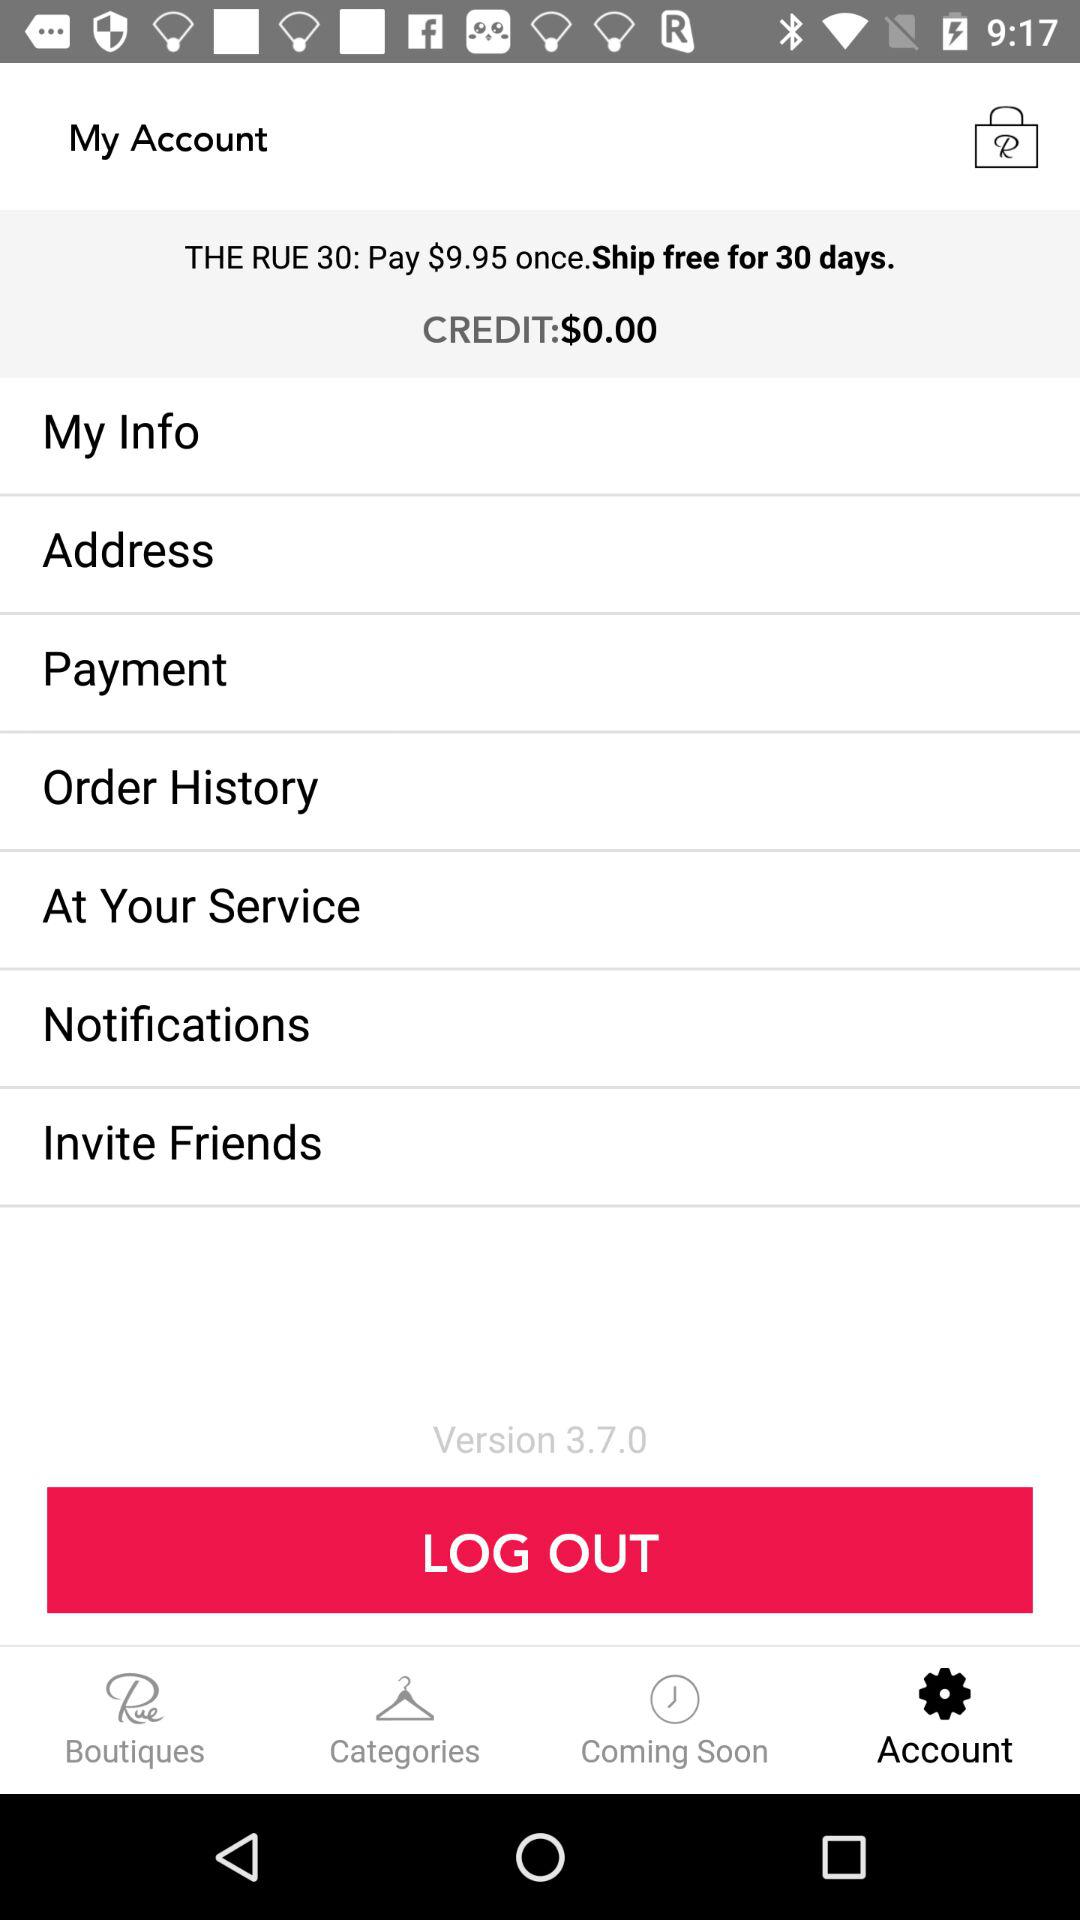How much credit do I have?
Answer the question using a single word or phrase. $0.00 